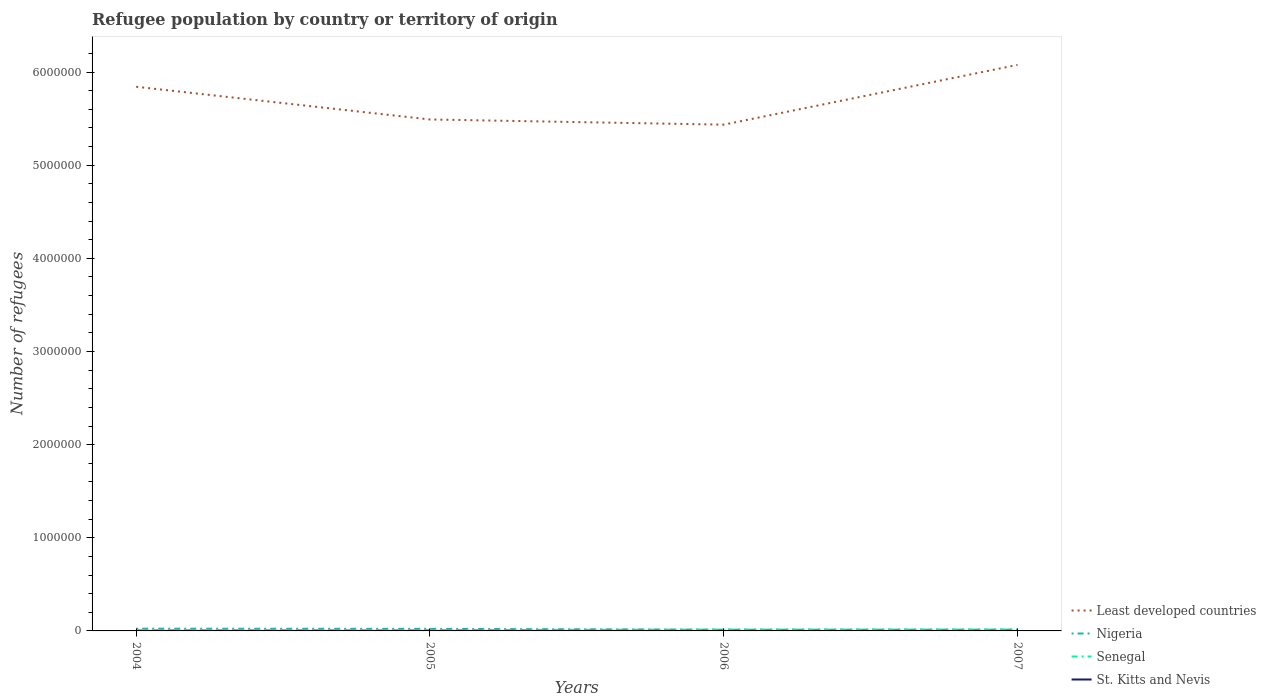Across all years, what is the maximum number of refugees in Nigeria?
Provide a short and direct response. 1.33e+04. In which year was the number of refugees in Least developed countries maximum?
Your response must be concise. 2006. What is the total number of refugees in Nigeria in the graph?
Your answer should be very brief. 1764. What is the difference between the highest and the lowest number of refugees in Senegal?
Offer a terse response. 2. How many years are there in the graph?
Provide a short and direct response. 4. What is the difference between two consecutive major ticks on the Y-axis?
Offer a terse response. 1.00e+06. Does the graph contain any zero values?
Your answer should be very brief. No. How are the legend labels stacked?
Your answer should be very brief. Vertical. What is the title of the graph?
Your answer should be compact. Refugee population by country or territory of origin. What is the label or title of the Y-axis?
Your answer should be compact. Number of refugees. What is the Number of refugees in Least developed countries in 2004?
Give a very brief answer. 5.84e+06. What is the Number of refugees in Nigeria in 2004?
Your answer should be compact. 2.39e+04. What is the Number of refugees of Senegal in 2004?
Keep it short and to the point. 8332. What is the Number of refugees of Least developed countries in 2005?
Your answer should be very brief. 5.49e+06. What is the Number of refugees in Nigeria in 2005?
Your response must be concise. 2.21e+04. What is the Number of refugees of Senegal in 2005?
Keep it short and to the point. 8671. What is the Number of refugees of St. Kitts and Nevis in 2005?
Provide a short and direct response. 31. What is the Number of refugees of Least developed countries in 2006?
Give a very brief answer. 5.44e+06. What is the Number of refugees in Nigeria in 2006?
Ensure brevity in your answer.  1.33e+04. What is the Number of refugees in Senegal in 2006?
Offer a terse response. 1.52e+04. What is the Number of refugees in St. Kitts and Nevis in 2006?
Offer a very short reply. 2. What is the Number of refugees in Least developed countries in 2007?
Ensure brevity in your answer.  6.08e+06. What is the Number of refugees of Nigeria in 2007?
Make the answer very short. 1.39e+04. What is the Number of refugees in Senegal in 2007?
Your answer should be compact. 1.59e+04. Across all years, what is the maximum Number of refugees in Least developed countries?
Your response must be concise. 6.08e+06. Across all years, what is the maximum Number of refugees of Nigeria?
Make the answer very short. 2.39e+04. Across all years, what is the maximum Number of refugees in Senegal?
Give a very brief answer. 1.59e+04. Across all years, what is the minimum Number of refugees in Least developed countries?
Your answer should be very brief. 5.44e+06. Across all years, what is the minimum Number of refugees in Nigeria?
Provide a succinct answer. 1.33e+04. Across all years, what is the minimum Number of refugees of Senegal?
Offer a terse response. 8332. Across all years, what is the minimum Number of refugees of St. Kitts and Nevis?
Offer a terse response. 1. What is the total Number of refugees of Least developed countries in the graph?
Keep it short and to the point. 2.28e+07. What is the total Number of refugees of Nigeria in the graph?
Offer a terse response. 7.32e+04. What is the total Number of refugees of Senegal in the graph?
Make the answer very short. 4.81e+04. What is the total Number of refugees in St. Kitts and Nevis in the graph?
Offer a very short reply. 36. What is the difference between the Number of refugees of Least developed countries in 2004 and that in 2005?
Give a very brief answer. 3.51e+05. What is the difference between the Number of refugees in Nigeria in 2004 and that in 2005?
Provide a short and direct response. 1764. What is the difference between the Number of refugees of Senegal in 2004 and that in 2005?
Make the answer very short. -339. What is the difference between the Number of refugees in Least developed countries in 2004 and that in 2006?
Provide a short and direct response. 4.07e+05. What is the difference between the Number of refugees of Nigeria in 2004 and that in 2006?
Ensure brevity in your answer.  1.06e+04. What is the difference between the Number of refugees in Senegal in 2004 and that in 2006?
Provide a short and direct response. -6831. What is the difference between the Number of refugees in St. Kitts and Nevis in 2004 and that in 2006?
Offer a very short reply. -1. What is the difference between the Number of refugees in Least developed countries in 2004 and that in 2007?
Your answer should be compact. -2.35e+05. What is the difference between the Number of refugees of Nigeria in 2004 and that in 2007?
Your answer should be compact. 9988. What is the difference between the Number of refugees of Senegal in 2004 and that in 2007?
Your answer should be compact. -7564. What is the difference between the Number of refugees of Least developed countries in 2005 and that in 2006?
Give a very brief answer. 5.57e+04. What is the difference between the Number of refugees of Nigeria in 2005 and that in 2006?
Your answer should be very brief. 8875. What is the difference between the Number of refugees in Senegal in 2005 and that in 2006?
Your answer should be very brief. -6492. What is the difference between the Number of refugees of St. Kitts and Nevis in 2005 and that in 2006?
Your answer should be very brief. 29. What is the difference between the Number of refugees of Least developed countries in 2005 and that in 2007?
Provide a short and direct response. -5.86e+05. What is the difference between the Number of refugees of Nigeria in 2005 and that in 2007?
Offer a very short reply. 8224. What is the difference between the Number of refugees in Senegal in 2005 and that in 2007?
Keep it short and to the point. -7225. What is the difference between the Number of refugees in Least developed countries in 2006 and that in 2007?
Give a very brief answer. -6.42e+05. What is the difference between the Number of refugees of Nigeria in 2006 and that in 2007?
Keep it short and to the point. -651. What is the difference between the Number of refugees in Senegal in 2006 and that in 2007?
Your answer should be very brief. -733. What is the difference between the Number of refugees of St. Kitts and Nevis in 2006 and that in 2007?
Offer a terse response. 0. What is the difference between the Number of refugees in Least developed countries in 2004 and the Number of refugees in Nigeria in 2005?
Offer a terse response. 5.82e+06. What is the difference between the Number of refugees of Least developed countries in 2004 and the Number of refugees of Senegal in 2005?
Your response must be concise. 5.83e+06. What is the difference between the Number of refugees in Least developed countries in 2004 and the Number of refugees in St. Kitts and Nevis in 2005?
Your answer should be compact. 5.84e+06. What is the difference between the Number of refugees of Nigeria in 2004 and the Number of refugees of Senegal in 2005?
Provide a short and direct response. 1.52e+04. What is the difference between the Number of refugees of Nigeria in 2004 and the Number of refugees of St. Kitts and Nevis in 2005?
Make the answer very short. 2.39e+04. What is the difference between the Number of refugees of Senegal in 2004 and the Number of refugees of St. Kitts and Nevis in 2005?
Your response must be concise. 8301. What is the difference between the Number of refugees in Least developed countries in 2004 and the Number of refugees in Nigeria in 2006?
Offer a terse response. 5.83e+06. What is the difference between the Number of refugees in Least developed countries in 2004 and the Number of refugees in Senegal in 2006?
Offer a very short reply. 5.83e+06. What is the difference between the Number of refugees of Least developed countries in 2004 and the Number of refugees of St. Kitts and Nevis in 2006?
Make the answer very short. 5.84e+06. What is the difference between the Number of refugees in Nigeria in 2004 and the Number of refugees in Senegal in 2006?
Your response must be concise. 8729. What is the difference between the Number of refugees of Nigeria in 2004 and the Number of refugees of St. Kitts and Nevis in 2006?
Your response must be concise. 2.39e+04. What is the difference between the Number of refugees in Senegal in 2004 and the Number of refugees in St. Kitts and Nevis in 2006?
Provide a short and direct response. 8330. What is the difference between the Number of refugees in Least developed countries in 2004 and the Number of refugees in Nigeria in 2007?
Provide a succinct answer. 5.83e+06. What is the difference between the Number of refugees in Least developed countries in 2004 and the Number of refugees in Senegal in 2007?
Provide a short and direct response. 5.83e+06. What is the difference between the Number of refugees of Least developed countries in 2004 and the Number of refugees of St. Kitts and Nevis in 2007?
Your response must be concise. 5.84e+06. What is the difference between the Number of refugees of Nigeria in 2004 and the Number of refugees of Senegal in 2007?
Offer a very short reply. 7996. What is the difference between the Number of refugees in Nigeria in 2004 and the Number of refugees in St. Kitts and Nevis in 2007?
Keep it short and to the point. 2.39e+04. What is the difference between the Number of refugees of Senegal in 2004 and the Number of refugees of St. Kitts and Nevis in 2007?
Provide a short and direct response. 8330. What is the difference between the Number of refugees in Least developed countries in 2005 and the Number of refugees in Nigeria in 2006?
Your answer should be compact. 5.48e+06. What is the difference between the Number of refugees in Least developed countries in 2005 and the Number of refugees in Senegal in 2006?
Ensure brevity in your answer.  5.48e+06. What is the difference between the Number of refugees in Least developed countries in 2005 and the Number of refugees in St. Kitts and Nevis in 2006?
Your answer should be very brief. 5.49e+06. What is the difference between the Number of refugees of Nigeria in 2005 and the Number of refugees of Senegal in 2006?
Offer a terse response. 6965. What is the difference between the Number of refugees of Nigeria in 2005 and the Number of refugees of St. Kitts and Nevis in 2006?
Your response must be concise. 2.21e+04. What is the difference between the Number of refugees of Senegal in 2005 and the Number of refugees of St. Kitts and Nevis in 2006?
Your answer should be very brief. 8669. What is the difference between the Number of refugees in Least developed countries in 2005 and the Number of refugees in Nigeria in 2007?
Provide a succinct answer. 5.48e+06. What is the difference between the Number of refugees in Least developed countries in 2005 and the Number of refugees in Senegal in 2007?
Offer a terse response. 5.48e+06. What is the difference between the Number of refugees in Least developed countries in 2005 and the Number of refugees in St. Kitts and Nevis in 2007?
Keep it short and to the point. 5.49e+06. What is the difference between the Number of refugees in Nigeria in 2005 and the Number of refugees in Senegal in 2007?
Your answer should be very brief. 6232. What is the difference between the Number of refugees of Nigeria in 2005 and the Number of refugees of St. Kitts and Nevis in 2007?
Keep it short and to the point. 2.21e+04. What is the difference between the Number of refugees of Senegal in 2005 and the Number of refugees of St. Kitts and Nevis in 2007?
Your answer should be very brief. 8669. What is the difference between the Number of refugees in Least developed countries in 2006 and the Number of refugees in Nigeria in 2007?
Your answer should be very brief. 5.42e+06. What is the difference between the Number of refugees of Least developed countries in 2006 and the Number of refugees of Senegal in 2007?
Provide a succinct answer. 5.42e+06. What is the difference between the Number of refugees of Least developed countries in 2006 and the Number of refugees of St. Kitts and Nevis in 2007?
Keep it short and to the point. 5.44e+06. What is the difference between the Number of refugees of Nigeria in 2006 and the Number of refugees of Senegal in 2007?
Give a very brief answer. -2643. What is the difference between the Number of refugees of Nigeria in 2006 and the Number of refugees of St. Kitts and Nevis in 2007?
Your response must be concise. 1.33e+04. What is the difference between the Number of refugees in Senegal in 2006 and the Number of refugees in St. Kitts and Nevis in 2007?
Make the answer very short. 1.52e+04. What is the average Number of refugees of Least developed countries per year?
Give a very brief answer. 5.71e+06. What is the average Number of refugees in Nigeria per year?
Your answer should be very brief. 1.83e+04. What is the average Number of refugees in Senegal per year?
Keep it short and to the point. 1.20e+04. In the year 2004, what is the difference between the Number of refugees of Least developed countries and Number of refugees of Nigeria?
Keep it short and to the point. 5.82e+06. In the year 2004, what is the difference between the Number of refugees in Least developed countries and Number of refugees in Senegal?
Give a very brief answer. 5.83e+06. In the year 2004, what is the difference between the Number of refugees in Least developed countries and Number of refugees in St. Kitts and Nevis?
Keep it short and to the point. 5.84e+06. In the year 2004, what is the difference between the Number of refugees of Nigeria and Number of refugees of Senegal?
Provide a succinct answer. 1.56e+04. In the year 2004, what is the difference between the Number of refugees in Nigeria and Number of refugees in St. Kitts and Nevis?
Your answer should be compact. 2.39e+04. In the year 2004, what is the difference between the Number of refugees in Senegal and Number of refugees in St. Kitts and Nevis?
Provide a short and direct response. 8331. In the year 2005, what is the difference between the Number of refugees of Least developed countries and Number of refugees of Nigeria?
Provide a succinct answer. 5.47e+06. In the year 2005, what is the difference between the Number of refugees of Least developed countries and Number of refugees of Senegal?
Offer a terse response. 5.48e+06. In the year 2005, what is the difference between the Number of refugees of Least developed countries and Number of refugees of St. Kitts and Nevis?
Ensure brevity in your answer.  5.49e+06. In the year 2005, what is the difference between the Number of refugees of Nigeria and Number of refugees of Senegal?
Offer a very short reply. 1.35e+04. In the year 2005, what is the difference between the Number of refugees in Nigeria and Number of refugees in St. Kitts and Nevis?
Provide a succinct answer. 2.21e+04. In the year 2005, what is the difference between the Number of refugees in Senegal and Number of refugees in St. Kitts and Nevis?
Offer a very short reply. 8640. In the year 2006, what is the difference between the Number of refugees of Least developed countries and Number of refugees of Nigeria?
Give a very brief answer. 5.42e+06. In the year 2006, what is the difference between the Number of refugees of Least developed countries and Number of refugees of Senegal?
Your response must be concise. 5.42e+06. In the year 2006, what is the difference between the Number of refugees of Least developed countries and Number of refugees of St. Kitts and Nevis?
Give a very brief answer. 5.44e+06. In the year 2006, what is the difference between the Number of refugees of Nigeria and Number of refugees of Senegal?
Your answer should be compact. -1910. In the year 2006, what is the difference between the Number of refugees of Nigeria and Number of refugees of St. Kitts and Nevis?
Offer a very short reply. 1.33e+04. In the year 2006, what is the difference between the Number of refugees of Senegal and Number of refugees of St. Kitts and Nevis?
Provide a succinct answer. 1.52e+04. In the year 2007, what is the difference between the Number of refugees in Least developed countries and Number of refugees in Nigeria?
Your response must be concise. 6.06e+06. In the year 2007, what is the difference between the Number of refugees of Least developed countries and Number of refugees of Senegal?
Your answer should be very brief. 6.06e+06. In the year 2007, what is the difference between the Number of refugees in Least developed countries and Number of refugees in St. Kitts and Nevis?
Provide a succinct answer. 6.08e+06. In the year 2007, what is the difference between the Number of refugees in Nigeria and Number of refugees in Senegal?
Your answer should be very brief. -1992. In the year 2007, what is the difference between the Number of refugees of Nigeria and Number of refugees of St. Kitts and Nevis?
Your response must be concise. 1.39e+04. In the year 2007, what is the difference between the Number of refugees of Senegal and Number of refugees of St. Kitts and Nevis?
Offer a very short reply. 1.59e+04. What is the ratio of the Number of refugees of Least developed countries in 2004 to that in 2005?
Your answer should be very brief. 1.06. What is the ratio of the Number of refugees of Nigeria in 2004 to that in 2005?
Keep it short and to the point. 1.08. What is the ratio of the Number of refugees of Senegal in 2004 to that in 2005?
Provide a succinct answer. 0.96. What is the ratio of the Number of refugees in St. Kitts and Nevis in 2004 to that in 2005?
Make the answer very short. 0.03. What is the ratio of the Number of refugees of Least developed countries in 2004 to that in 2006?
Provide a short and direct response. 1.07. What is the ratio of the Number of refugees of Nigeria in 2004 to that in 2006?
Make the answer very short. 1.8. What is the ratio of the Number of refugees of Senegal in 2004 to that in 2006?
Keep it short and to the point. 0.55. What is the ratio of the Number of refugees in Least developed countries in 2004 to that in 2007?
Give a very brief answer. 0.96. What is the ratio of the Number of refugees in Nigeria in 2004 to that in 2007?
Your answer should be very brief. 1.72. What is the ratio of the Number of refugees of Senegal in 2004 to that in 2007?
Give a very brief answer. 0.52. What is the ratio of the Number of refugees of Least developed countries in 2005 to that in 2006?
Your answer should be compact. 1.01. What is the ratio of the Number of refugees in Nigeria in 2005 to that in 2006?
Ensure brevity in your answer.  1.67. What is the ratio of the Number of refugees in Senegal in 2005 to that in 2006?
Offer a very short reply. 0.57. What is the ratio of the Number of refugees of Least developed countries in 2005 to that in 2007?
Offer a very short reply. 0.9. What is the ratio of the Number of refugees in Nigeria in 2005 to that in 2007?
Keep it short and to the point. 1.59. What is the ratio of the Number of refugees of Senegal in 2005 to that in 2007?
Give a very brief answer. 0.55. What is the ratio of the Number of refugees of Least developed countries in 2006 to that in 2007?
Your answer should be very brief. 0.89. What is the ratio of the Number of refugees of Nigeria in 2006 to that in 2007?
Your answer should be compact. 0.95. What is the ratio of the Number of refugees of Senegal in 2006 to that in 2007?
Provide a succinct answer. 0.95. What is the difference between the highest and the second highest Number of refugees in Least developed countries?
Provide a short and direct response. 2.35e+05. What is the difference between the highest and the second highest Number of refugees of Nigeria?
Keep it short and to the point. 1764. What is the difference between the highest and the second highest Number of refugees in Senegal?
Your response must be concise. 733. What is the difference between the highest and the second highest Number of refugees in St. Kitts and Nevis?
Your answer should be compact. 29. What is the difference between the highest and the lowest Number of refugees of Least developed countries?
Your answer should be very brief. 6.42e+05. What is the difference between the highest and the lowest Number of refugees in Nigeria?
Give a very brief answer. 1.06e+04. What is the difference between the highest and the lowest Number of refugees in Senegal?
Provide a short and direct response. 7564. 